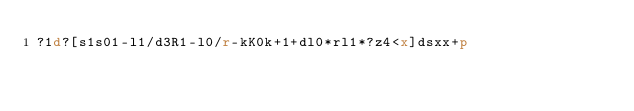Convert code to text. <code><loc_0><loc_0><loc_500><loc_500><_dc_>?1d?[s1s01-l1/d3R1-l0/r-kK0k+1+dl0*rl1*?z4<x]dsxx+p</code> 